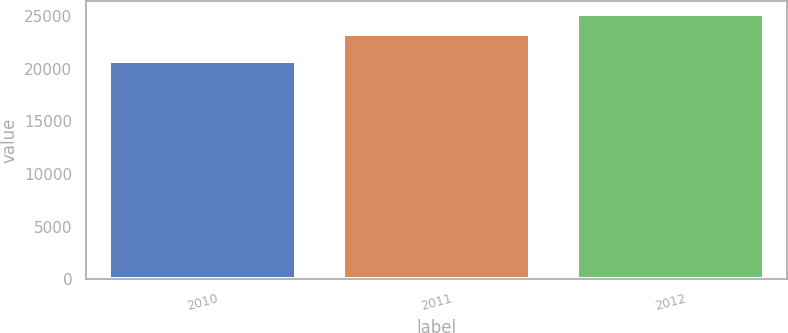Convert chart to OTSL. <chart><loc_0><loc_0><loc_500><loc_500><bar_chart><fcel>2010<fcel>2011<fcel>2012<nl><fcel>20747<fcel>23277<fcel>25209<nl></chart> 